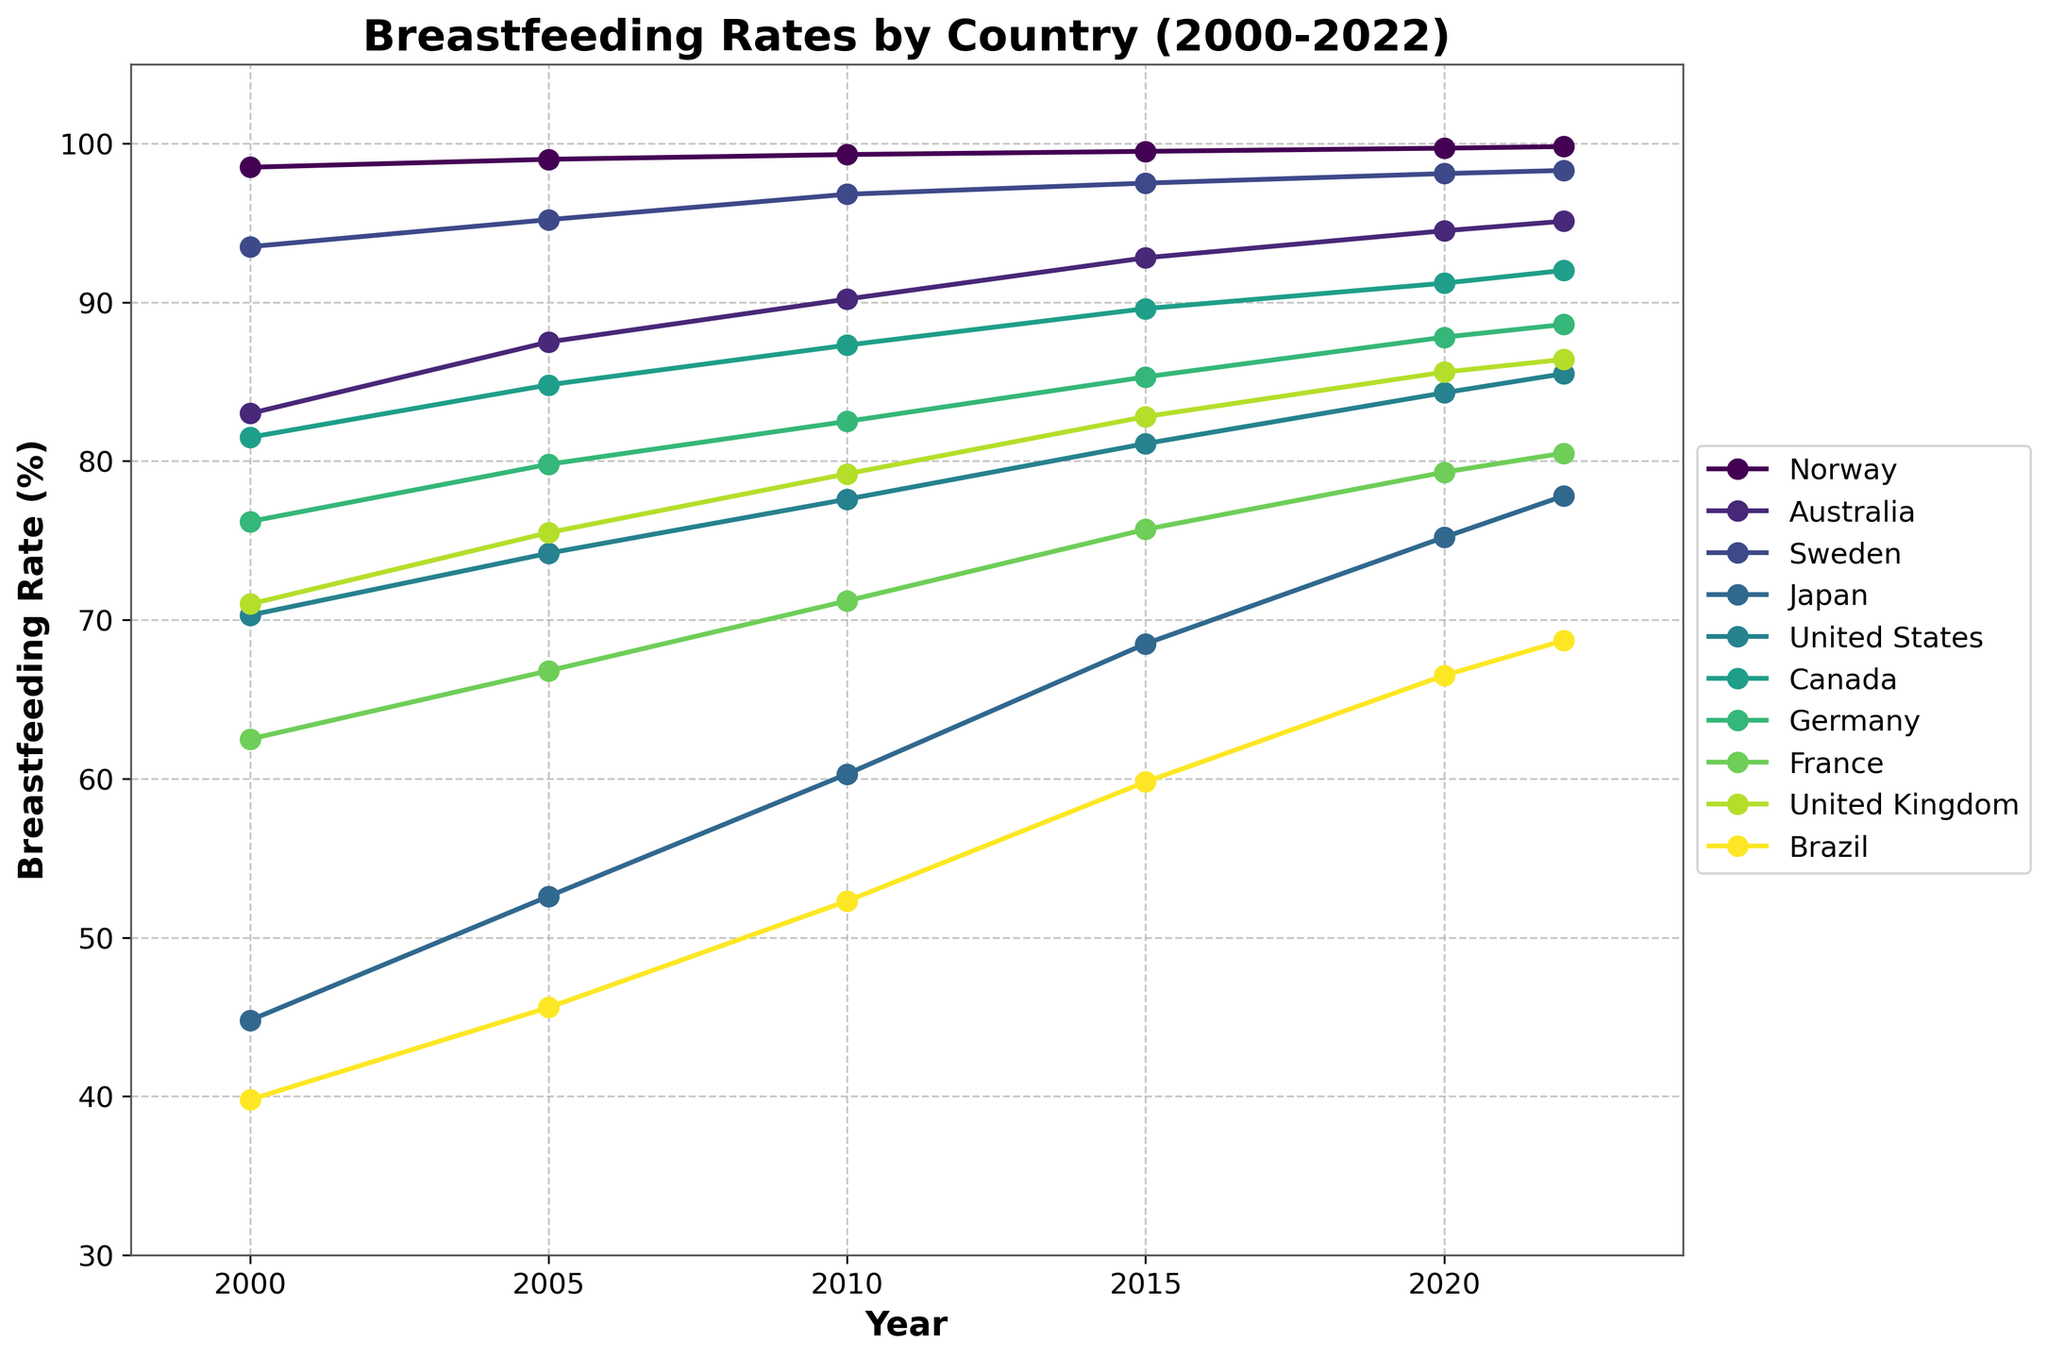Which country had the highest breastfeeding rate in 2022? By looking at the end of the lines representing 2022 and finding the highest point, it is clear that Norway had the highest breastfeeding rate.
Answer: Norway Which country showed the most significant increase in breastfeeding rates from 2000 to 2022? To find this, the difference between the 2022 and 2000 rate for each country needs to be calculated. Norway (99.8 - 98.5 = 1.3), Australia (95.1 - 83 = 12.1), Sweden (98.3 - 93.5 = 4.8), Japan (77.8 - 44.8 = 33), United States (85.5 - 70.3 = 15.2), Canada (92 - 81.5 = 10.5), Germany (88.6 - 76.2 = 12.4), France (80.5 - 62.5 = 18), United Kingdom (86.4 - 71 = 15.4), Brazil (68.7 - 39.8 = 28.9). Therefore, Japan had the most significant increase.
Answer: Japan Which two countries had the closest breastfeeding rates in 2015? By comparing the values in 2015, the closest rates are: Norway (99.5), Australia (92.8), Sweden (97.5), Japan (68.5), United States (81.1), Canada (89.6), Germany (85.3), France (75.7), United Kingdom (82.8), Brazil (59.8). The closest values are United States (81.1) and United Kingdom (82.8), with a difference of only 1.7%.
Answer: United States and United Kingdom Did any country decrease its breastfeeding rate from 2010 to 2020? Checking the values from 2010 to 2020 for each country: Norway (99.3 to 99.7), Australia (90.2 to 94.5), Sweden (96.8 to 98.1), Japan (60.3 to 75.2), United States (77.6 to 84.3), Canada (87.3 to 91.2), Germany (82.5 to 87.8), France (71.2 to 79.3), United Kingdom (79.2 to 85.6), Brazil (52.3 to 66.5). No country showed a decrease.
Answer: No Which country had a breastfeeding rate closest to 85% in 2020? Looking at the rates in 2020: Norway (99.7), Australia (94.5), Sweden (98.1), Japan (75.2), United States (84.3), Canada (91.2), Germany (87.8), France (79.3), United Kingdom (85.6), Brazil (66.5). The United Kingdom had a rate closest to 85%.
Answer: United Kingdom What was the average breastfeeding rate in Sweden from 2000 to 2022? To find the average, sum the rates of 2000, 2005, 2010, 2015, 2020, 2022: 93.5 + 95.2 + 96.8 + 97.5 + 98.1 + 98.3 = 579.4. Then divide by 6: 579.4 / 6 = 96.57.
Answer: 96.57% How did the breastfeeding rate in France compare between 2005 and 2010? The breastfeeding rate in France in 2005 was 66.8, and in 2010, it was 71.2. 71.2 - 66.8 = 4.4, so the rate increased by 4.4%.
Answer: Increased by 4.4% Which country had the least increase in breastfeeding rates between 2000 and 2022? Subtracting the 2000 rate from the 2022 rate for each country, Norway (99.8 - 98.5 = 1.3), Australia (95.1 - 83 = 12.1), Sweden (98.3 - 93.5 = 4.8), Japan (77.8 - 44.8 = 33), United States (85.5 - 70.3 = 15.2), Canada (92 - 81.5 = 10.5), Germany (88.6 - 76.2 = 12.4), France (80.5 - 62.5 = 18), United Kingdom (86.4 - 71 = 15.4), Brazil (68.7 - 39.8 = 28.9). Norway had the least increase.
Answer: Norway Which country's breastfeeding rates remained closest to a stable linear increase? By visually inspecting the graph, Australia, with a smooth and steadily increasing line, shows the most consistent linear increase compared to others with more variation.
Answer: Australia 